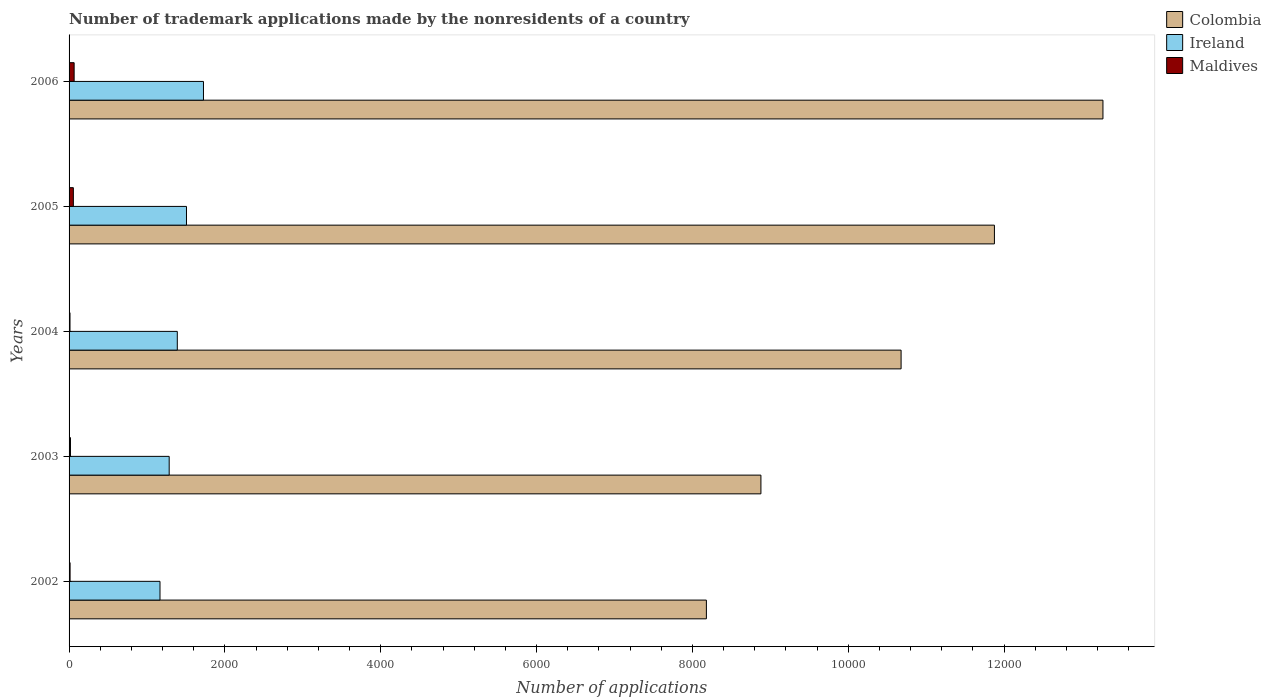How many groups of bars are there?
Give a very brief answer. 5. Are the number of bars per tick equal to the number of legend labels?
Provide a short and direct response. Yes. Are the number of bars on each tick of the Y-axis equal?
Ensure brevity in your answer.  Yes. How many bars are there on the 3rd tick from the bottom?
Provide a short and direct response. 3. What is the label of the 4th group of bars from the top?
Your answer should be very brief. 2003. Across all years, what is the minimum number of trademark applications made by the nonresidents in Maldives?
Your answer should be very brief. 12. In which year was the number of trademark applications made by the nonresidents in Colombia maximum?
Give a very brief answer. 2006. What is the total number of trademark applications made by the nonresidents in Maldives in the graph?
Offer a terse response. 163. What is the difference between the number of trademark applications made by the nonresidents in Colombia in 2004 and that in 2005?
Offer a very short reply. -1198. What is the difference between the number of trademark applications made by the nonresidents in Colombia in 2004 and the number of trademark applications made by the nonresidents in Maldives in 2002?
Your answer should be very brief. 1.07e+04. What is the average number of trademark applications made by the nonresidents in Maldives per year?
Your answer should be very brief. 32.6. In the year 2004, what is the difference between the number of trademark applications made by the nonresidents in Ireland and number of trademark applications made by the nonresidents in Maldives?
Offer a very short reply. 1377. In how many years, is the number of trademark applications made by the nonresidents in Maldives greater than 3600 ?
Provide a succinct answer. 0. What is the ratio of the number of trademark applications made by the nonresidents in Maldives in 2002 to that in 2003?
Keep it short and to the point. 0.72. What is the difference between the highest and the lowest number of trademark applications made by the nonresidents in Ireland?
Offer a very short reply. 558. In how many years, is the number of trademark applications made by the nonresidents in Maldives greater than the average number of trademark applications made by the nonresidents in Maldives taken over all years?
Give a very brief answer. 2. What does the 2nd bar from the top in 2004 represents?
Provide a succinct answer. Ireland. What does the 2nd bar from the bottom in 2002 represents?
Your answer should be compact. Ireland. Is it the case that in every year, the sum of the number of trademark applications made by the nonresidents in Maldives and number of trademark applications made by the nonresidents in Colombia is greater than the number of trademark applications made by the nonresidents in Ireland?
Offer a terse response. Yes. How many bars are there?
Keep it short and to the point. 15. How many years are there in the graph?
Give a very brief answer. 5. What is the difference between two consecutive major ticks on the X-axis?
Keep it short and to the point. 2000. Does the graph contain any zero values?
Offer a very short reply. No. How many legend labels are there?
Keep it short and to the point. 3. How are the legend labels stacked?
Give a very brief answer. Vertical. What is the title of the graph?
Your answer should be very brief. Number of trademark applications made by the nonresidents of a country. What is the label or title of the X-axis?
Offer a terse response. Number of applications. What is the Number of applications in Colombia in 2002?
Your answer should be compact. 8180. What is the Number of applications in Ireland in 2002?
Make the answer very short. 1167. What is the Number of applications in Colombia in 2003?
Provide a short and direct response. 8880. What is the Number of applications of Ireland in 2003?
Offer a very short reply. 1285. What is the Number of applications of Maldives in 2003?
Give a very brief answer. 18. What is the Number of applications of Colombia in 2004?
Your answer should be very brief. 1.07e+04. What is the Number of applications in Ireland in 2004?
Ensure brevity in your answer.  1389. What is the Number of applications in Colombia in 2005?
Give a very brief answer. 1.19e+04. What is the Number of applications in Ireland in 2005?
Your response must be concise. 1507. What is the Number of applications of Maldives in 2005?
Ensure brevity in your answer.  55. What is the Number of applications of Colombia in 2006?
Make the answer very short. 1.33e+04. What is the Number of applications of Ireland in 2006?
Offer a terse response. 1725. What is the Number of applications of Maldives in 2006?
Your response must be concise. 65. Across all years, what is the maximum Number of applications of Colombia?
Your answer should be very brief. 1.33e+04. Across all years, what is the maximum Number of applications of Ireland?
Your answer should be compact. 1725. Across all years, what is the maximum Number of applications of Maldives?
Provide a succinct answer. 65. Across all years, what is the minimum Number of applications in Colombia?
Ensure brevity in your answer.  8180. Across all years, what is the minimum Number of applications of Ireland?
Your answer should be compact. 1167. What is the total Number of applications of Colombia in the graph?
Provide a succinct answer. 5.29e+04. What is the total Number of applications in Ireland in the graph?
Make the answer very short. 7073. What is the total Number of applications in Maldives in the graph?
Provide a succinct answer. 163. What is the difference between the Number of applications in Colombia in 2002 and that in 2003?
Give a very brief answer. -700. What is the difference between the Number of applications of Ireland in 2002 and that in 2003?
Your answer should be compact. -118. What is the difference between the Number of applications in Colombia in 2002 and that in 2004?
Make the answer very short. -2499. What is the difference between the Number of applications in Ireland in 2002 and that in 2004?
Ensure brevity in your answer.  -222. What is the difference between the Number of applications in Colombia in 2002 and that in 2005?
Provide a short and direct response. -3697. What is the difference between the Number of applications of Ireland in 2002 and that in 2005?
Your response must be concise. -340. What is the difference between the Number of applications of Maldives in 2002 and that in 2005?
Provide a short and direct response. -42. What is the difference between the Number of applications in Colombia in 2002 and that in 2006?
Provide a succinct answer. -5090. What is the difference between the Number of applications in Ireland in 2002 and that in 2006?
Your response must be concise. -558. What is the difference between the Number of applications of Maldives in 2002 and that in 2006?
Provide a short and direct response. -52. What is the difference between the Number of applications in Colombia in 2003 and that in 2004?
Your answer should be compact. -1799. What is the difference between the Number of applications of Ireland in 2003 and that in 2004?
Provide a succinct answer. -104. What is the difference between the Number of applications of Maldives in 2003 and that in 2004?
Give a very brief answer. 6. What is the difference between the Number of applications of Colombia in 2003 and that in 2005?
Offer a very short reply. -2997. What is the difference between the Number of applications of Ireland in 2003 and that in 2005?
Give a very brief answer. -222. What is the difference between the Number of applications of Maldives in 2003 and that in 2005?
Give a very brief answer. -37. What is the difference between the Number of applications in Colombia in 2003 and that in 2006?
Your response must be concise. -4390. What is the difference between the Number of applications in Ireland in 2003 and that in 2006?
Provide a succinct answer. -440. What is the difference between the Number of applications in Maldives in 2003 and that in 2006?
Offer a terse response. -47. What is the difference between the Number of applications of Colombia in 2004 and that in 2005?
Provide a short and direct response. -1198. What is the difference between the Number of applications of Ireland in 2004 and that in 2005?
Your response must be concise. -118. What is the difference between the Number of applications in Maldives in 2004 and that in 2005?
Your response must be concise. -43. What is the difference between the Number of applications of Colombia in 2004 and that in 2006?
Ensure brevity in your answer.  -2591. What is the difference between the Number of applications of Ireland in 2004 and that in 2006?
Your answer should be compact. -336. What is the difference between the Number of applications of Maldives in 2004 and that in 2006?
Your response must be concise. -53. What is the difference between the Number of applications in Colombia in 2005 and that in 2006?
Provide a succinct answer. -1393. What is the difference between the Number of applications in Ireland in 2005 and that in 2006?
Offer a terse response. -218. What is the difference between the Number of applications in Maldives in 2005 and that in 2006?
Offer a terse response. -10. What is the difference between the Number of applications of Colombia in 2002 and the Number of applications of Ireland in 2003?
Keep it short and to the point. 6895. What is the difference between the Number of applications of Colombia in 2002 and the Number of applications of Maldives in 2003?
Provide a short and direct response. 8162. What is the difference between the Number of applications in Ireland in 2002 and the Number of applications in Maldives in 2003?
Offer a very short reply. 1149. What is the difference between the Number of applications in Colombia in 2002 and the Number of applications in Ireland in 2004?
Keep it short and to the point. 6791. What is the difference between the Number of applications in Colombia in 2002 and the Number of applications in Maldives in 2004?
Your answer should be compact. 8168. What is the difference between the Number of applications of Ireland in 2002 and the Number of applications of Maldives in 2004?
Give a very brief answer. 1155. What is the difference between the Number of applications in Colombia in 2002 and the Number of applications in Ireland in 2005?
Ensure brevity in your answer.  6673. What is the difference between the Number of applications in Colombia in 2002 and the Number of applications in Maldives in 2005?
Your answer should be very brief. 8125. What is the difference between the Number of applications in Ireland in 2002 and the Number of applications in Maldives in 2005?
Make the answer very short. 1112. What is the difference between the Number of applications of Colombia in 2002 and the Number of applications of Ireland in 2006?
Offer a terse response. 6455. What is the difference between the Number of applications of Colombia in 2002 and the Number of applications of Maldives in 2006?
Make the answer very short. 8115. What is the difference between the Number of applications of Ireland in 2002 and the Number of applications of Maldives in 2006?
Give a very brief answer. 1102. What is the difference between the Number of applications in Colombia in 2003 and the Number of applications in Ireland in 2004?
Provide a short and direct response. 7491. What is the difference between the Number of applications of Colombia in 2003 and the Number of applications of Maldives in 2004?
Give a very brief answer. 8868. What is the difference between the Number of applications in Ireland in 2003 and the Number of applications in Maldives in 2004?
Provide a succinct answer. 1273. What is the difference between the Number of applications of Colombia in 2003 and the Number of applications of Ireland in 2005?
Offer a very short reply. 7373. What is the difference between the Number of applications of Colombia in 2003 and the Number of applications of Maldives in 2005?
Make the answer very short. 8825. What is the difference between the Number of applications in Ireland in 2003 and the Number of applications in Maldives in 2005?
Your answer should be very brief. 1230. What is the difference between the Number of applications of Colombia in 2003 and the Number of applications of Ireland in 2006?
Make the answer very short. 7155. What is the difference between the Number of applications of Colombia in 2003 and the Number of applications of Maldives in 2006?
Offer a very short reply. 8815. What is the difference between the Number of applications of Ireland in 2003 and the Number of applications of Maldives in 2006?
Offer a very short reply. 1220. What is the difference between the Number of applications of Colombia in 2004 and the Number of applications of Ireland in 2005?
Keep it short and to the point. 9172. What is the difference between the Number of applications in Colombia in 2004 and the Number of applications in Maldives in 2005?
Give a very brief answer. 1.06e+04. What is the difference between the Number of applications in Ireland in 2004 and the Number of applications in Maldives in 2005?
Your answer should be very brief. 1334. What is the difference between the Number of applications of Colombia in 2004 and the Number of applications of Ireland in 2006?
Keep it short and to the point. 8954. What is the difference between the Number of applications in Colombia in 2004 and the Number of applications in Maldives in 2006?
Provide a short and direct response. 1.06e+04. What is the difference between the Number of applications of Ireland in 2004 and the Number of applications of Maldives in 2006?
Give a very brief answer. 1324. What is the difference between the Number of applications of Colombia in 2005 and the Number of applications of Ireland in 2006?
Offer a terse response. 1.02e+04. What is the difference between the Number of applications in Colombia in 2005 and the Number of applications in Maldives in 2006?
Make the answer very short. 1.18e+04. What is the difference between the Number of applications in Ireland in 2005 and the Number of applications in Maldives in 2006?
Make the answer very short. 1442. What is the average Number of applications of Colombia per year?
Your answer should be very brief. 1.06e+04. What is the average Number of applications in Ireland per year?
Your response must be concise. 1414.6. What is the average Number of applications in Maldives per year?
Your response must be concise. 32.6. In the year 2002, what is the difference between the Number of applications of Colombia and Number of applications of Ireland?
Offer a very short reply. 7013. In the year 2002, what is the difference between the Number of applications in Colombia and Number of applications in Maldives?
Ensure brevity in your answer.  8167. In the year 2002, what is the difference between the Number of applications of Ireland and Number of applications of Maldives?
Your answer should be very brief. 1154. In the year 2003, what is the difference between the Number of applications of Colombia and Number of applications of Ireland?
Your answer should be very brief. 7595. In the year 2003, what is the difference between the Number of applications in Colombia and Number of applications in Maldives?
Provide a succinct answer. 8862. In the year 2003, what is the difference between the Number of applications of Ireland and Number of applications of Maldives?
Provide a succinct answer. 1267. In the year 2004, what is the difference between the Number of applications of Colombia and Number of applications of Ireland?
Make the answer very short. 9290. In the year 2004, what is the difference between the Number of applications in Colombia and Number of applications in Maldives?
Your response must be concise. 1.07e+04. In the year 2004, what is the difference between the Number of applications of Ireland and Number of applications of Maldives?
Your answer should be very brief. 1377. In the year 2005, what is the difference between the Number of applications in Colombia and Number of applications in Ireland?
Provide a short and direct response. 1.04e+04. In the year 2005, what is the difference between the Number of applications of Colombia and Number of applications of Maldives?
Provide a short and direct response. 1.18e+04. In the year 2005, what is the difference between the Number of applications in Ireland and Number of applications in Maldives?
Your answer should be very brief. 1452. In the year 2006, what is the difference between the Number of applications of Colombia and Number of applications of Ireland?
Make the answer very short. 1.15e+04. In the year 2006, what is the difference between the Number of applications of Colombia and Number of applications of Maldives?
Offer a terse response. 1.32e+04. In the year 2006, what is the difference between the Number of applications of Ireland and Number of applications of Maldives?
Ensure brevity in your answer.  1660. What is the ratio of the Number of applications in Colombia in 2002 to that in 2003?
Offer a terse response. 0.92. What is the ratio of the Number of applications of Ireland in 2002 to that in 2003?
Your response must be concise. 0.91. What is the ratio of the Number of applications of Maldives in 2002 to that in 2003?
Keep it short and to the point. 0.72. What is the ratio of the Number of applications in Colombia in 2002 to that in 2004?
Offer a terse response. 0.77. What is the ratio of the Number of applications in Ireland in 2002 to that in 2004?
Your response must be concise. 0.84. What is the ratio of the Number of applications of Maldives in 2002 to that in 2004?
Keep it short and to the point. 1.08. What is the ratio of the Number of applications in Colombia in 2002 to that in 2005?
Keep it short and to the point. 0.69. What is the ratio of the Number of applications of Ireland in 2002 to that in 2005?
Keep it short and to the point. 0.77. What is the ratio of the Number of applications of Maldives in 2002 to that in 2005?
Make the answer very short. 0.24. What is the ratio of the Number of applications in Colombia in 2002 to that in 2006?
Keep it short and to the point. 0.62. What is the ratio of the Number of applications in Ireland in 2002 to that in 2006?
Make the answer very short. 0.68. What is the ratio of the Number of applications in Colombia in 2003 to that in 2004?
Your answer should be very brief. 0.83. What is the ratio of the Number of applications in Ireland in 2003 to that in 2004?
Provide a succinct answer. 0.93. What is the ratio of the Number of applications of Maldives in 2003 to that in 2004?
Your response must be concise. 1.5. What is the ratio of the Number of applications in Colombia in 2003 to that in 2005?
Ensure brevity in your answer.  0.75. What is the ratio of the Number of applications of Ireland in 2003 to that in 2005?
Your answer should be compact. 0.85. What is the ratio of the Number of applications in Maldives in 2003 to that in 2005?
Your answer should be compact. 0.33. What is the ratio of the Number of applications in Colombia in 2003 to that in 2006?
Offer a very short reply. 0.67. What is the ratio of the Number of applications of Ireland in 2003 to that in 2006?
Provide a short and direct response. 0.74. What is the ratio of the Number of applications of Maldives in 2003 to that in 2006?
Your response must be concise. 0.28. What is the ratio of the Number of applications of Colombia in 2004 to that in 2005?
Offer a terse response. 0.9. What is the ratio of the Number of applications in Ireland in 2004 to that in 2005?
Keep it short and to the point. 0.92. What is the ratio of the Number of applications of Maldives in 2004 to that in 2005?
Give a very brief answer. 0.22. What is the ratio of the Number of applications in Colombia in 2004 to that in 2006?
Provide a succinct answer. 0.8. What is the ratio of the Number of applications of Ireland in 2004 to that in 2006?
Your response must be concise. 0.81. What is the ratio of the Number of applications in Maldives in 2004 to that in 2006?
Ensure brevity in your answer.  0.18. What is the ratio of the Number of applications of Colombia in 2005 to that in 2006?
Keep it short and to the point. 0.9. What is the ratio of the Number of applications in Ireland in 2005 to that in 2006?
Ensure brevity in your answer.  0.87. What is the ratio of the Number of applications in Maldives in 2005 to that in 2006?
Your answer should be very brief. 0.85. What is the difference between the highest and the second highest Number of applications of Colombia?
Ensure brevity in your answer.  1393. What is the difference between the highest and the second highest Number of applications in Ireland?
Make the answer very short. 218. What is the difference between the highest and the lowest Number of applications of Colombia?
Your answer should be compact. 5090. What is the difference between the highest and the lowest Number of applications of Ireland?
Provide a short and direct response. 558. 